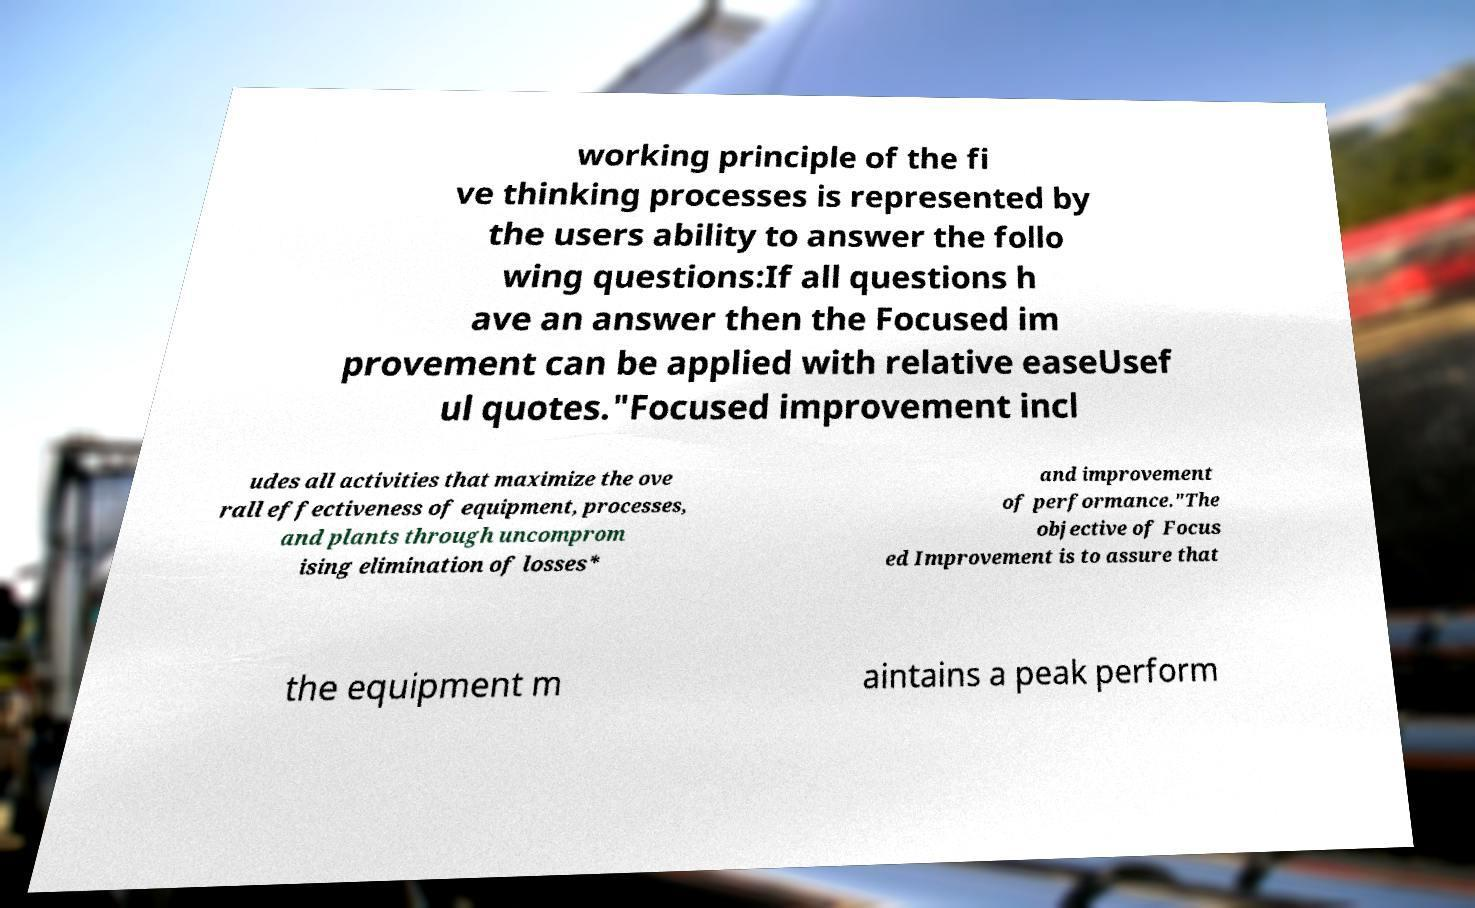Please read and relay the text visible in this image. What does it say? working principle of the fi ve thinking processes is represented by the users ability to answer the follo wing questions:If all questions h ave an answer then the Focused im provement can be applied with relative easeUsef ul quotes."Focused improvement incl udes all activities that maximize the ove rall effectiveness of equipment, processes, and plants through uncomprom ising elimination of losses* and improvement of performance."The objective of Focus ed Improvement is to assure that the equipment m aintains a peak perform 